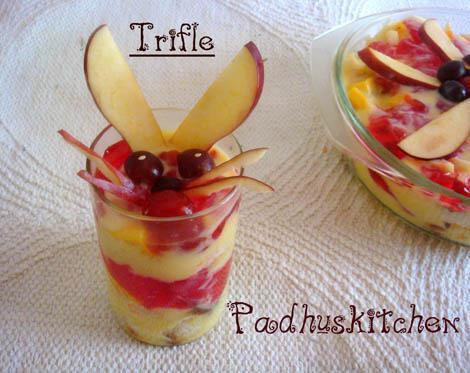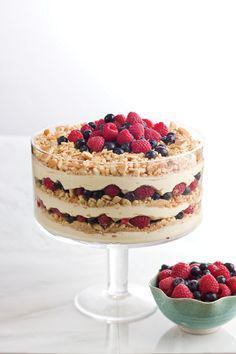The first image is the image on the left, the second image is the image on the right. Examine the images to the left and right. Is the description "There is exactly one container in the image on the right." accurate? Answer yes or no. No. 